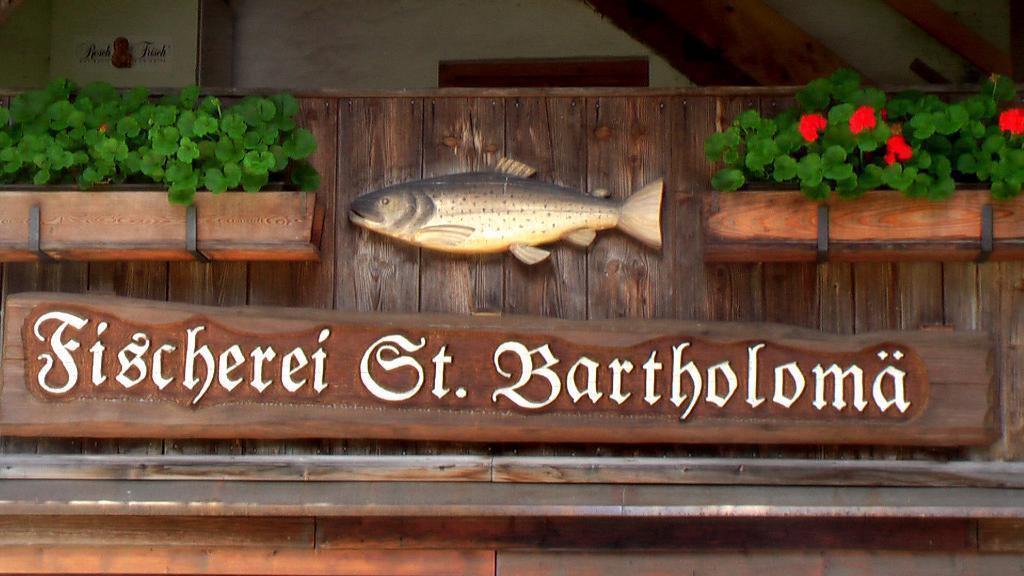Can you describe this image briefly? In this picture I can see wooden name plate. I can see wooden fish object. I can see the plants. 